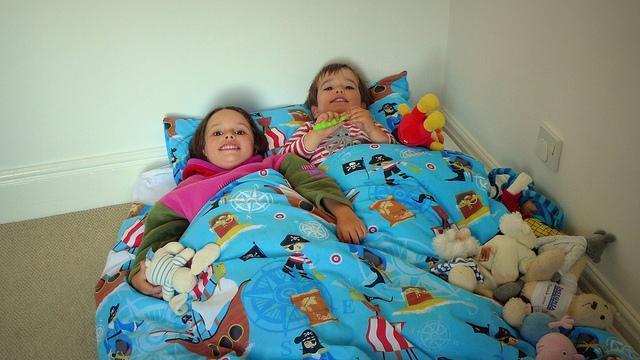How many children are in the picture?
Give a very brief answer. 2. How many teddy bears are visible?
Give a very brief answer. 3. How many people are in the photo?
Give a very brief answer. 2. 